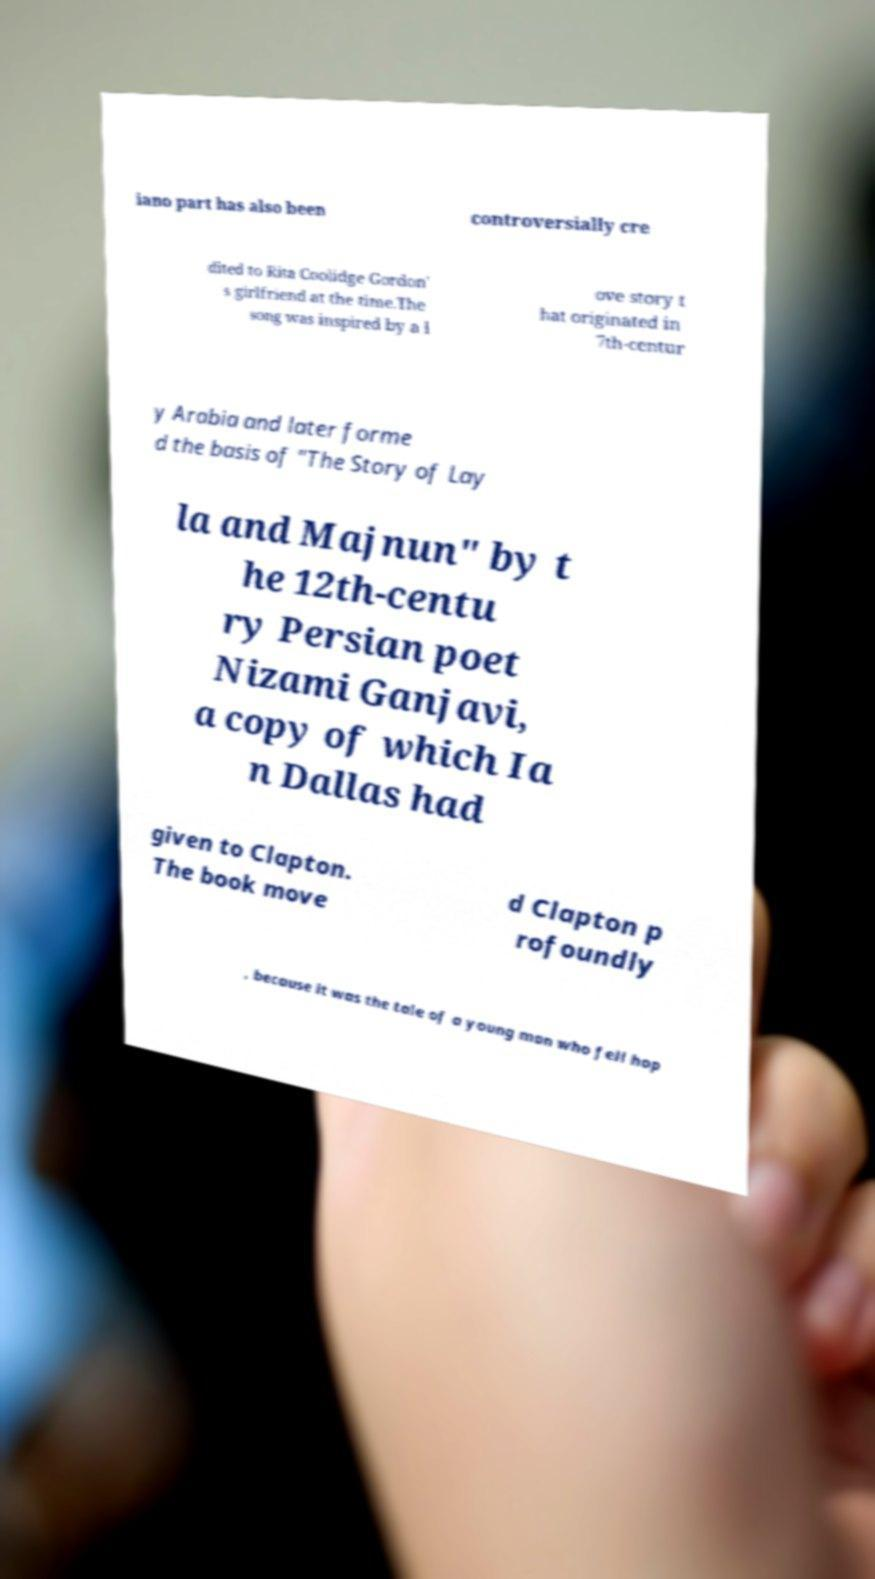Please identify and transcribe the text found in this image. iano part has also been controversially cre dited to Rita Coolidge Gordon' s girlfriend at the time.The song was inspired by a l ove story t hat originated in 7th-centur y Arabia and later forme d the basis of "The Story of Lay la and Majnun" by t he 12th-centu ry Persian poet Nizami Ganjavi, a copy of which Ia n Dallas had given to Clapton. The book move d Clapton p rofoundly , because it was the tale of a young man who fell hop 